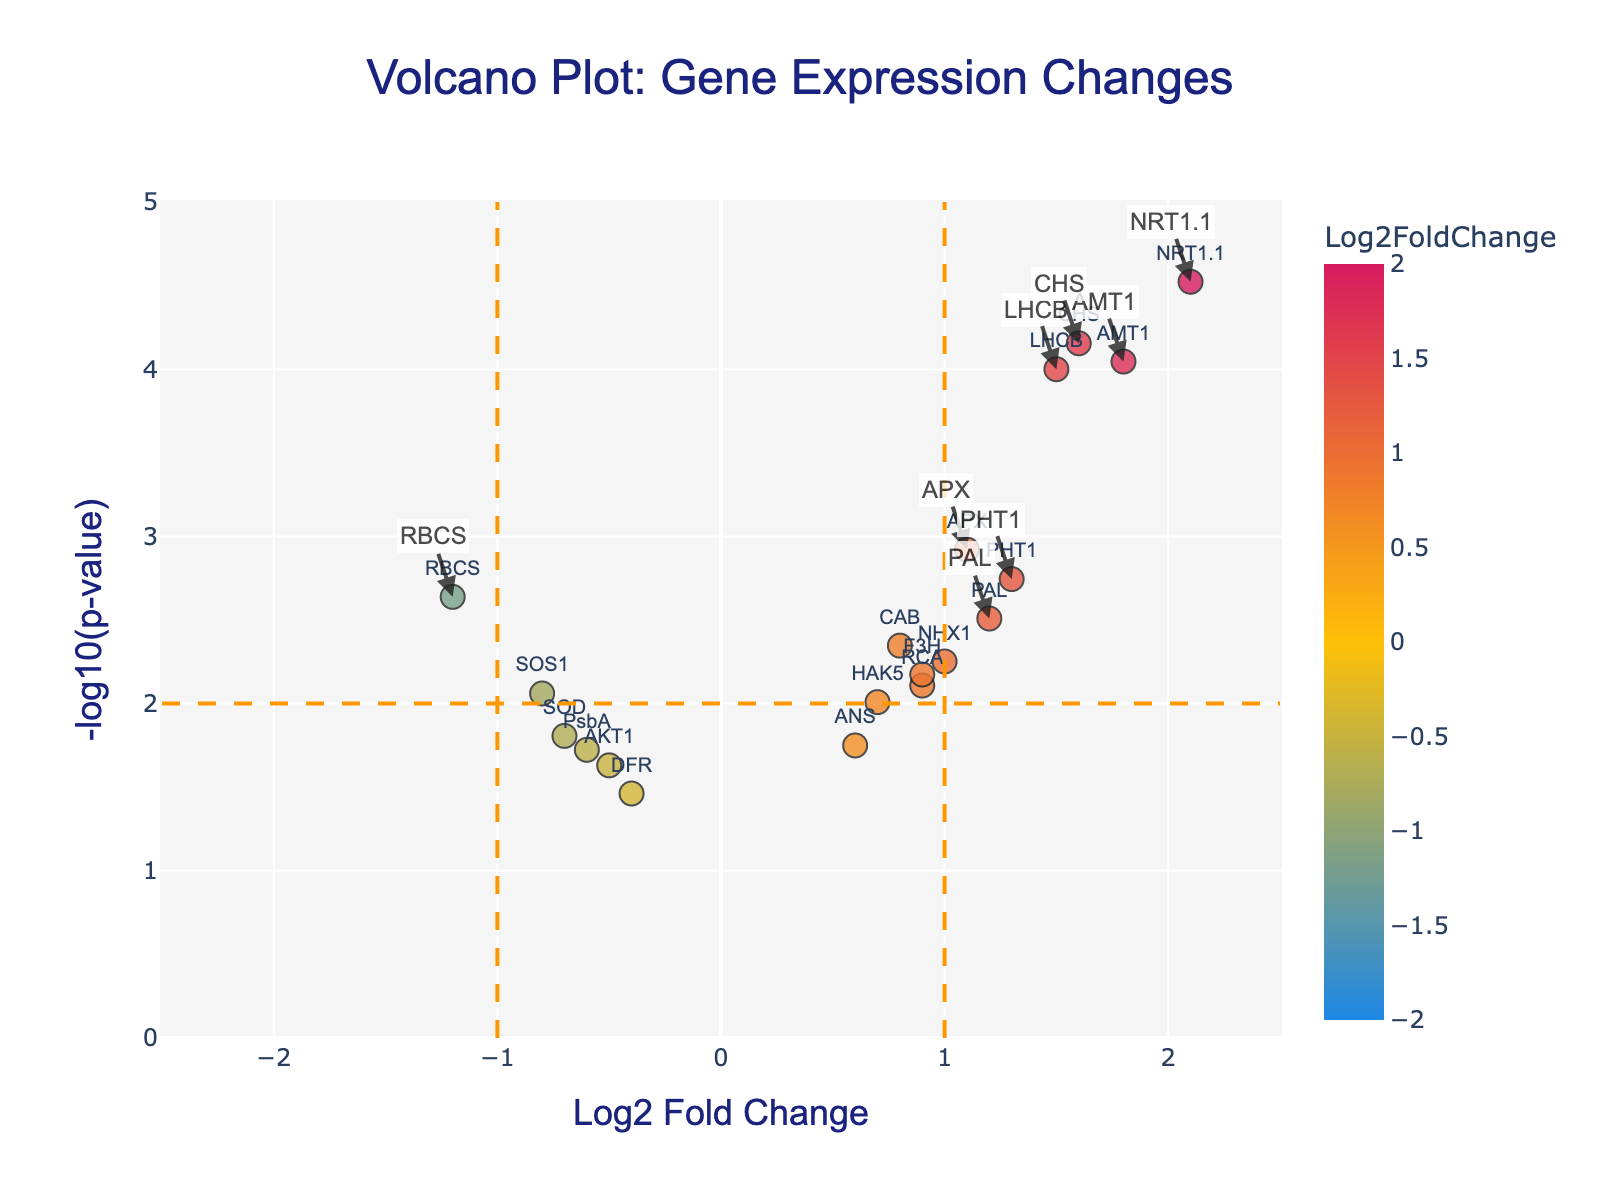What is the title of the volcano plot? The title is displayed at the top center of the plot, signifying the context and main focus of the figure.
Answer: Volcano Plot: Gene Expression Changes What are the axes labels in the volcano plot? The x-axis label is at the bottom of the plot, indicating the horizontal axis's measure. The y-axis label is on the left side, indicating the vertical axis's measure.
Answer: Log2 Fold Change (x-axis) and -log10(p-value) (y-axis) How many genes have a log2 fold change greater than 1? Identify data points on the right side of the x=1 threshold line and count them. These points have a Log2 Fold Change greater than 1.
Answer: 8 Which gene shows the highest expression change? Locate the data point with the highest absolute value on the x-axis. The gene corresponding to this point has the most significant expression change.
Answer: NRT1.1 How many genes have a -log10(p-value) greater than 2? Identify points above the y=2 threshold line and count them, as these satisfy the condition of having a -log10(p-value) greater than 2.
Answer: 11 Which gene is the most statistically significant based on the -log10(p-value)? Find the gene with the highest y-axis value, which has the highest -log10(p-value) and thus the most statistical significance.
Answer: NRT1.1 Which genes appear in the significantly upregulated region (Log2 Fold Change > 1 and -log10(p-value) > 2)? Focus on the top-right portion of the plot, above the y-axis threshold of 2 and to the right of the x-axis threshold of 1, then list those genes.
Answer: LHCB, NRT1.1, AMT1, PHT1, CHS Which genes are downregulated with a Log2 Fold Change less than -0.5 and a -log10(p-value) greater than 1? Identify and list genes that are below the -0.5 mark on the x-axis and above the 1 mark on the y-axis.
Answer: RBCS, SOD, AKT1, SOS1 What is the significance threshold for genes on the y-axis? Examine the horizontal dashed line that intersects the y-axis, indicating the significance threshold.
Answer: -log10(p-value) = 2 